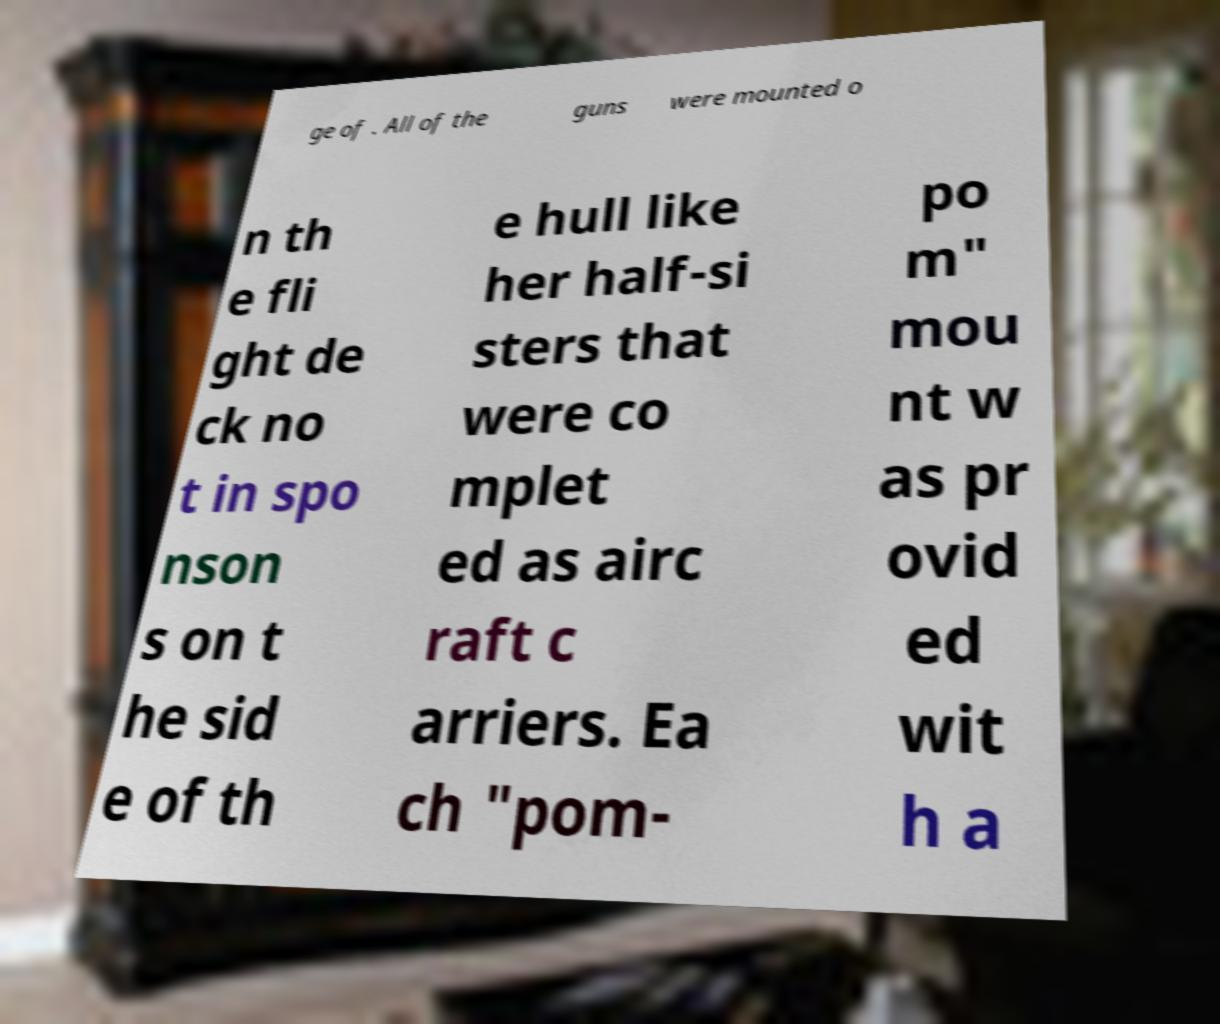Could you assist in decoding the text presented in this image and type it out clearly? ge of . All of the guns were mounted o n th e fli ght de ck no t in spo nson s on t he sid e of th e hull like her half-si sters that were co mplet ed as airc raft c arriers. Ea ch "pom- po m" mou nt w as pr ovid ed wit h a 